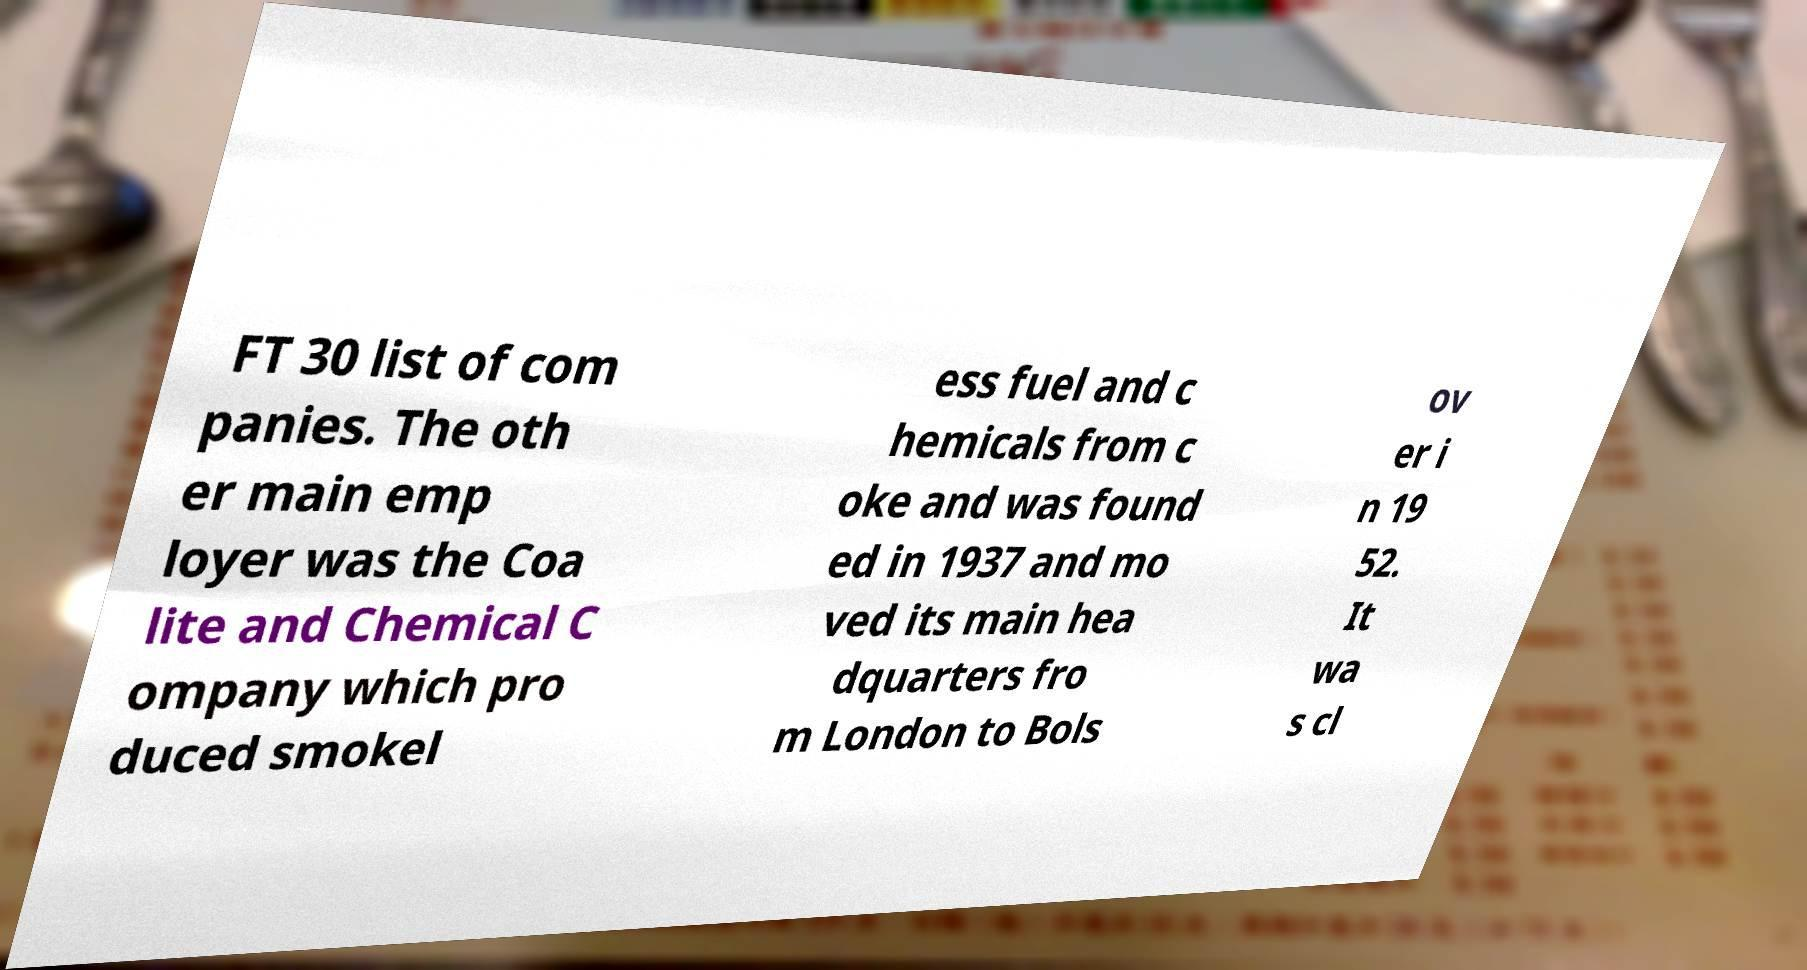What messages or text are displayed in this image? I need them in a readable, typed format. FT 30 list of com panies. The oth er main emp loyer was the Coa lite and Chemical C ompany which pro duced smokel ess fuel and c hemicals from c oke and was found ed in 1937 and mo ved its main hea dquarters fro m London to Bols ov er i n 19 52. It wa s cl 